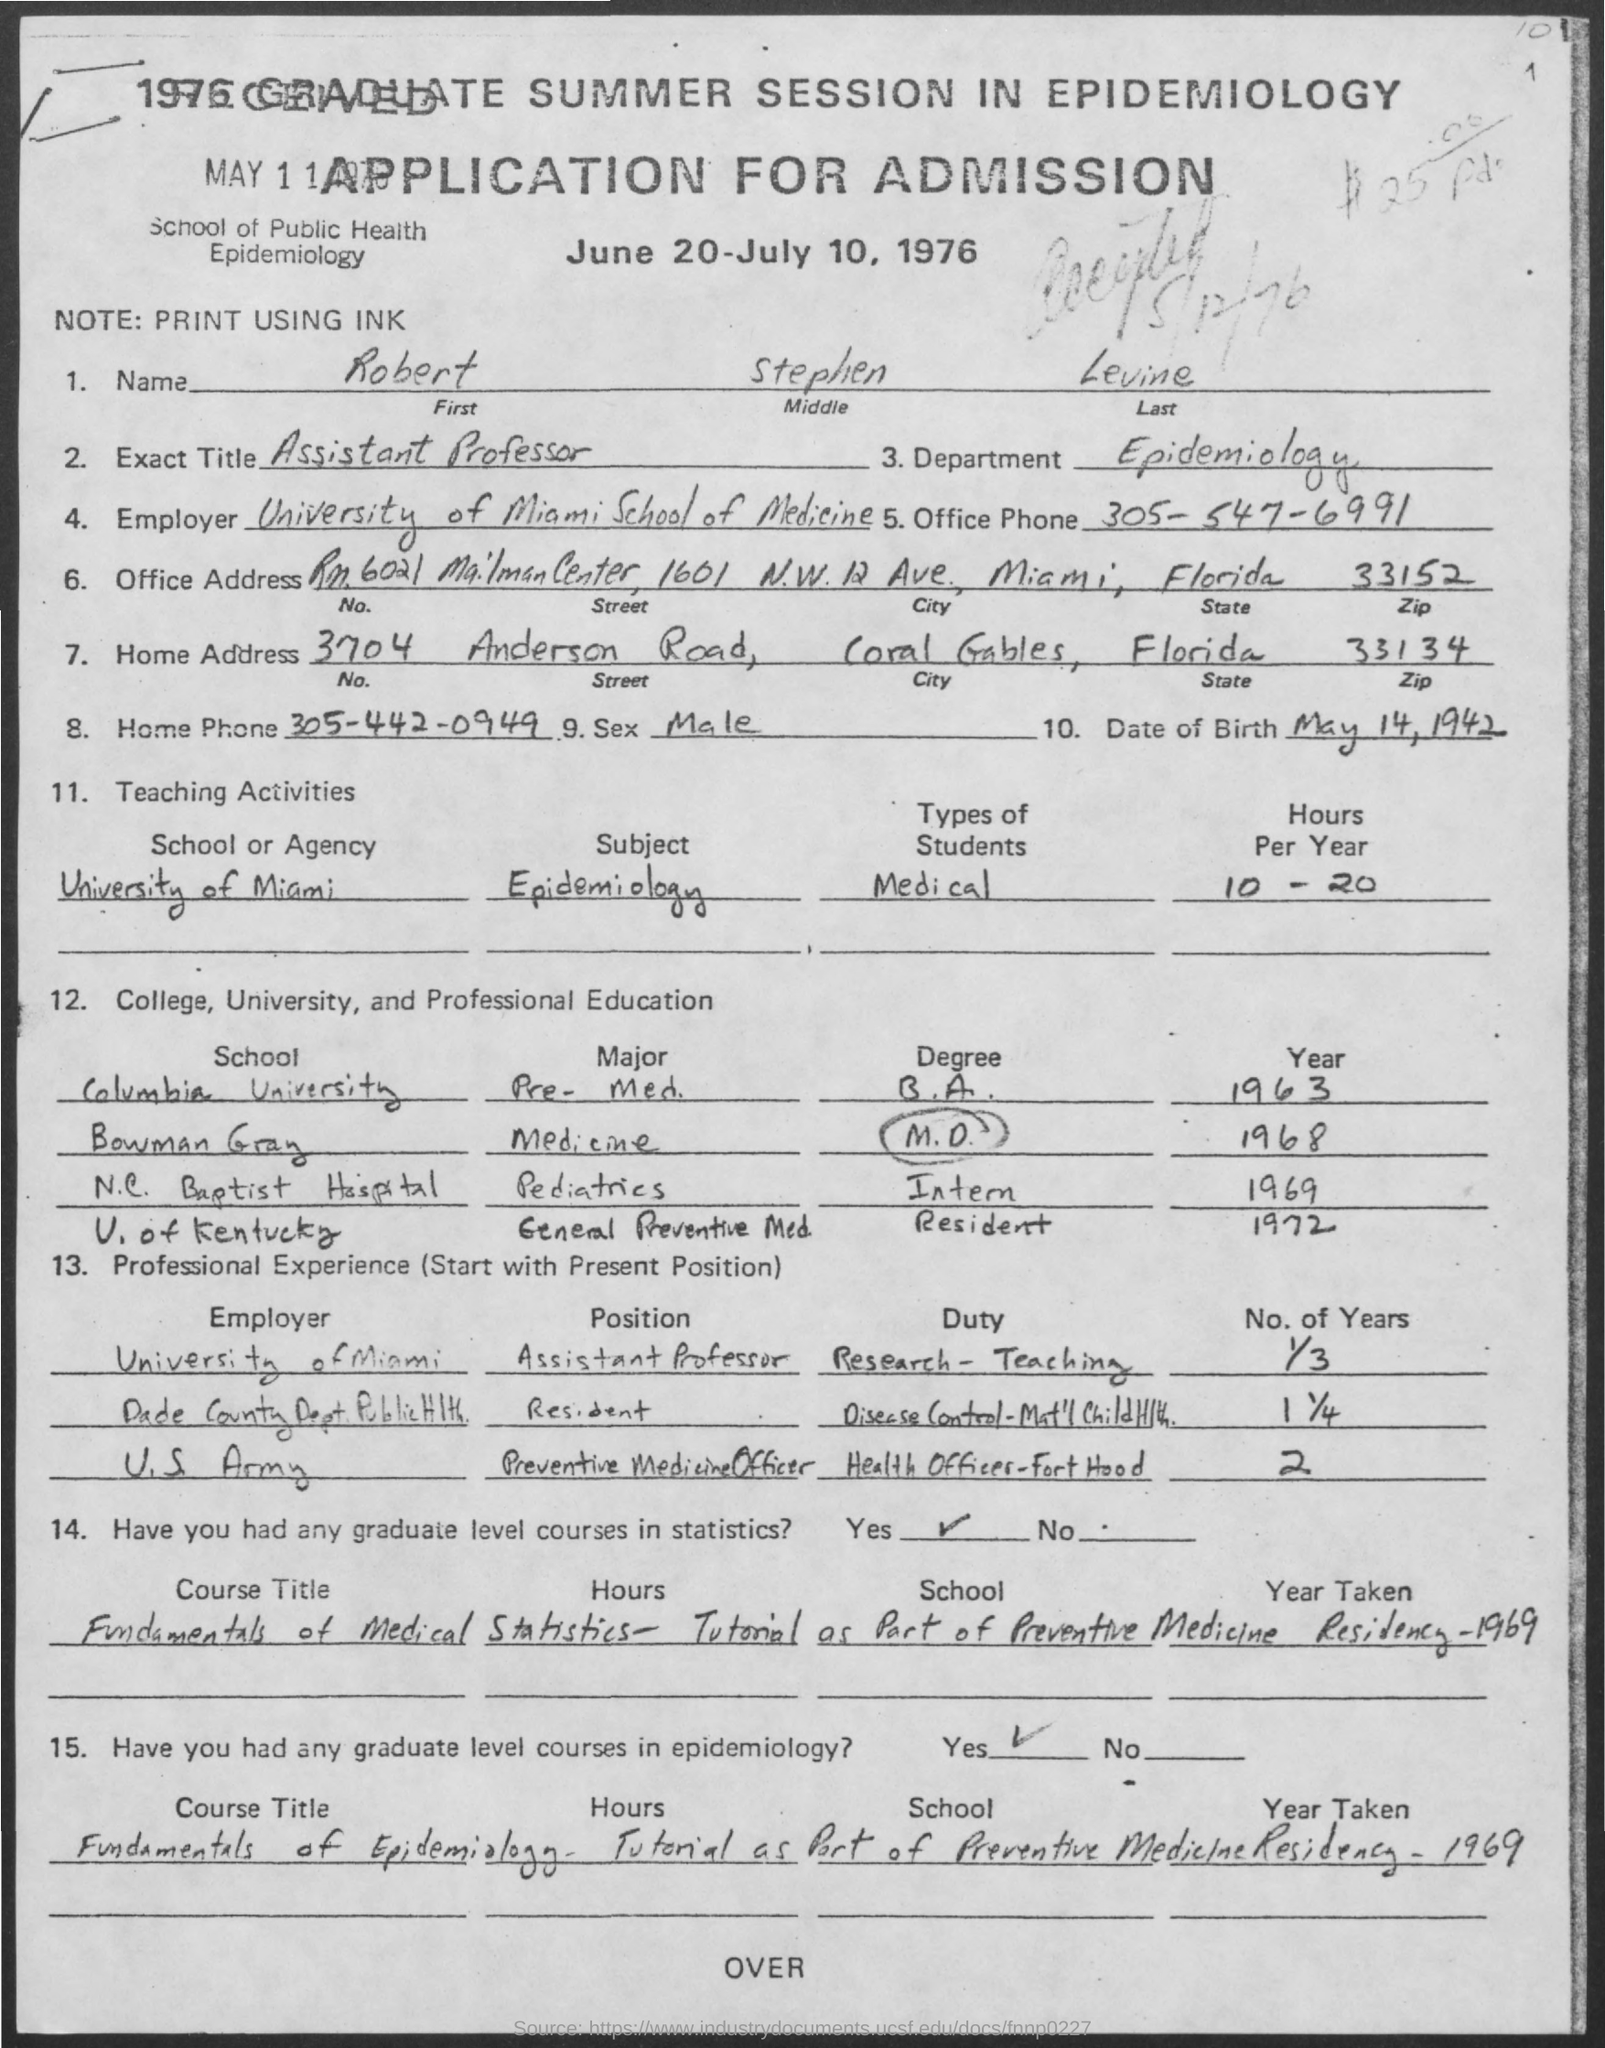Indicate a few pertinent items in this graphic. The name mentioned is Robert Stephen Levine. The home address on Anderson Road is mentioned in the text. The office phone number is 305-547-6991. The date of birth is May 14, 1942. The home phone number is 305-442-0949. 